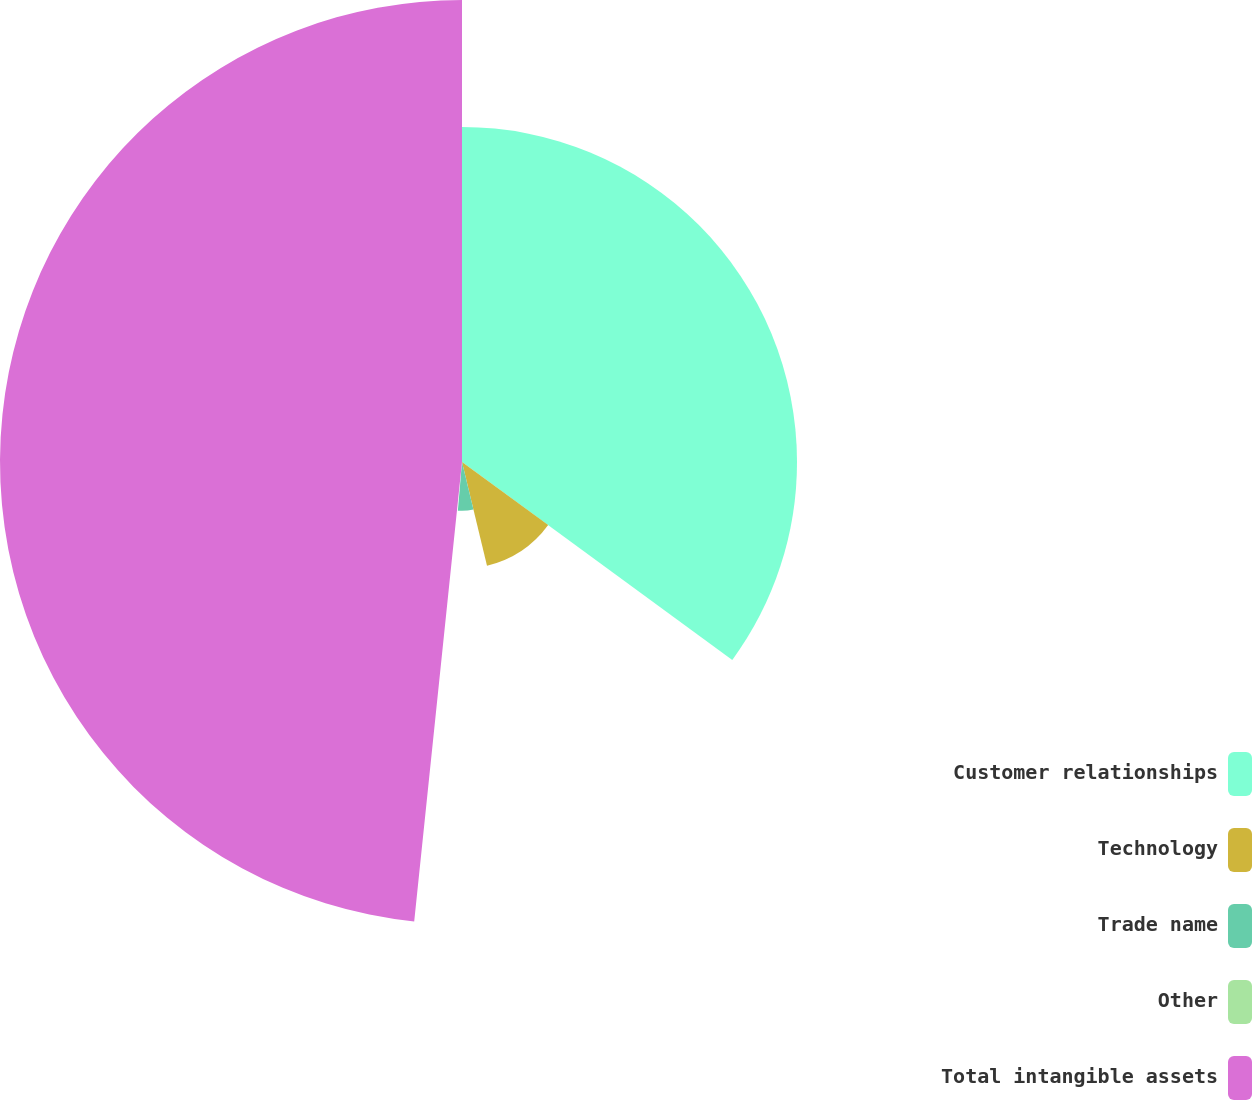Convert chart to OTSL. <chart><loc_0><loc_0><loc_500><loc_500><pie_chart><fcel>Customer relationships<fcel>Technology<fcel>Trade name<fcel>Other<fcel>Total intangible assets<nl><fcel>35.06%<fcel>11.18%<fcel>5.11%<fcel>0.3%<fcel>48.35%<nl></chart> 